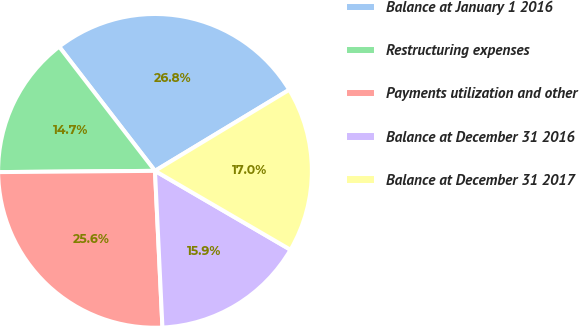Convert chart to OTSL. <chart><loc_0><loc_0><loc_500><loc_500><pie_chart><fcel>Balance at January 1 2016<fcel>Restructuring expenses<fcel>Payments utilization and other<fcel>Balance at December 31 2016<fcel>Balance at December 31 2017<nl><fcel>26.81%<fcel>14.67%<fcel>25.63%<fcel>15.85%<fcel>17.04%<nl></chart> 